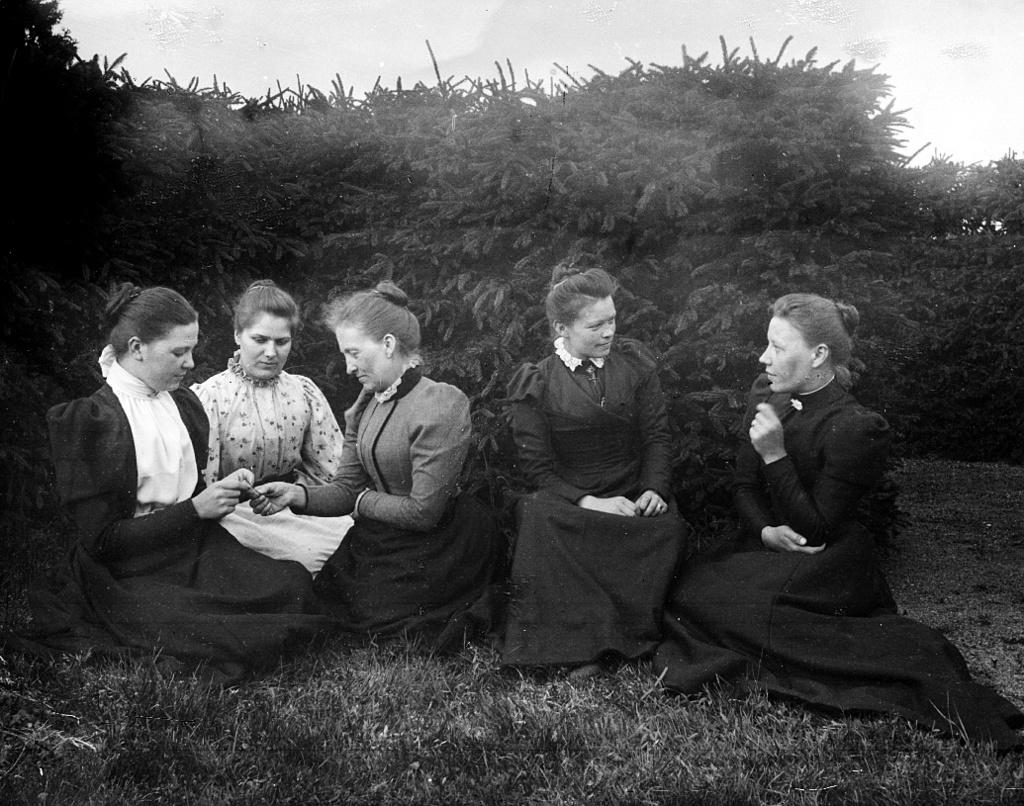What are the people in the image doing? The people in the image are sitting on the grass. What can be seen in the background of the image? There are trees and the sky visible in the background of the image. How many grapes can be seen in the image? There are no grapes present in the image. What is the person attempting to do in the image? There is no specific action or attempt being made by a person in the image; the people are simply sitting on the grass. 